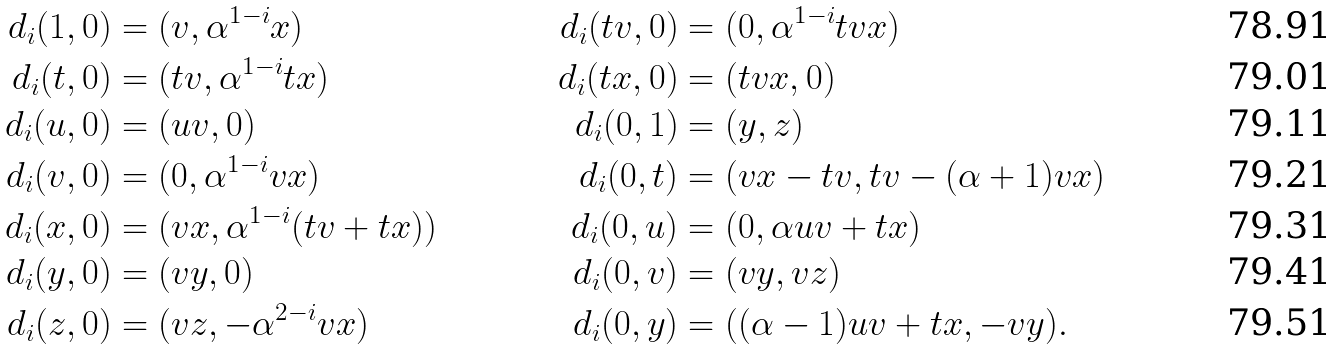<formula> <loc_0><loc_0><loc_500><loc_500>d _ { i } ( 1 , 0 ) & = ( v , \alpha ^ { 1 - i } x ) & d _ { i } ( t v , 0 ) & = ( 0 , \alpha ^ { 1 - i } t v x ) \\ d _ { i } ( t , 0 ) & = ( t v , \alpha ^ { 1 - i } t x ) & d _ { i } ( t x , 0 ) & = ( t v x , 0 ) \\ d _ { i } ( u , 0 ) & = ( u v , 0 ) & d _ { i } ( 0 , 1 ) & = ( y , z ) \\ d _ { i } ( v , 0 ) & = ( 0 , \alpha ^ { 1 - i } v x ) & d _ { i } ( 0 , t ) & = ( v x - t v , t v - ( \alpha + 1 ) v x ) \\ d _ { i } ( x , 0 ) & = ( v x , \alpha ^ { 1 - i } ( t v + t x ) ) & d _ { i } ( 0 , u ) & = ( 0 , \alpha u v + t x ) \\ d _ { i } ( y , 0 ) & = ( v y , 0 ) & d _ { i } ( 0 , v ) & = ( v y , v z ) \\ d _ { i } ( z , 0 ) & = ( v z , - \alpha ^ { 2 - i } v x ) & d _ { i } ( 0 , y ) & = ( ( \alpha - 1 ) u v + t x , - v y ) .</formula> 